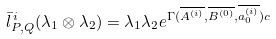Convert formula to latex. <formula><loc_0><loc_0><loc_500><loc_500>\bar { l } _ { P , Q } ^ { \, i } ( \lambda _ { 1 } \otimes \lambda _ { 2 } ) = \lambda _ { 1 } \lambda _ { 2 } e ^ { \Gamma ( \overline { A ^ { ( i ) } } , \overline { B ^ { ( 0 ) } } , \overline { a _ { 0 } ^ { ( i ) } } ) c }</formula> 